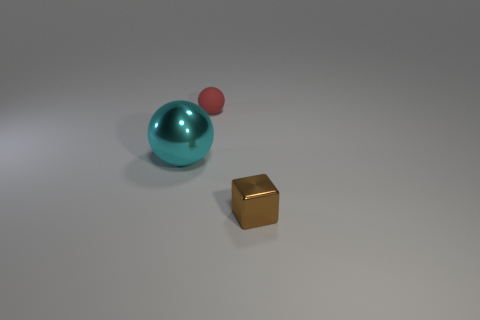Add 1 tiny gray metallic cubes. How many objects exist? 4 Subtract all spheres. How many objects are left? 1 Add 1 large spheres. How many large spheres are left? 2 Add 2 small green matte cubes. How many small green matte cubes exist? 2 Subtract 0 red cylinders. How many objects are left? 3 Subtract all brown matte cylinders. Subtract all small red rubber objects. How many objects are left? 2 